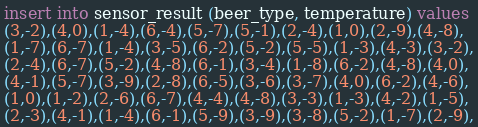<code> <loc_0><loc_0><loc_500><loc_500><_SQL_>insert into sensor_result (beer_type, temperature) values
(3,-2),(4,0),(1,-4),(6,-4),(5,-7),(5,-1),(2,-4),(1,0),(2,-9),(4,-8),
(1,-7),(6,-7),(1,-4),(3,-5),(6,-2),(5,-2),(5,-5),(1,-3),(4,-3),(3,-2),
(2,-4),(6,-7),(5,-2),(4,-8),(6,-1),(3,-4),(1,-8),(6,-2),(4,-8),(4,0),
(4,-1),(5,-7),(3,-9),(2,-8),(6,-5),(3,-6),(3,-7),(4,0),(6,-2),(4,-6),
(1,0),(1,-2),(2,-6),(6,-7),(4,-4),(4,-8),(3,-3),(1,-3),(4,-2),(1,-5),
(2,-3),(4,-1),(1,-4),(6,-1),(5,-9),(3,-9),(3,-8),(5,-2),(1,-7),(2,-9),</code> 